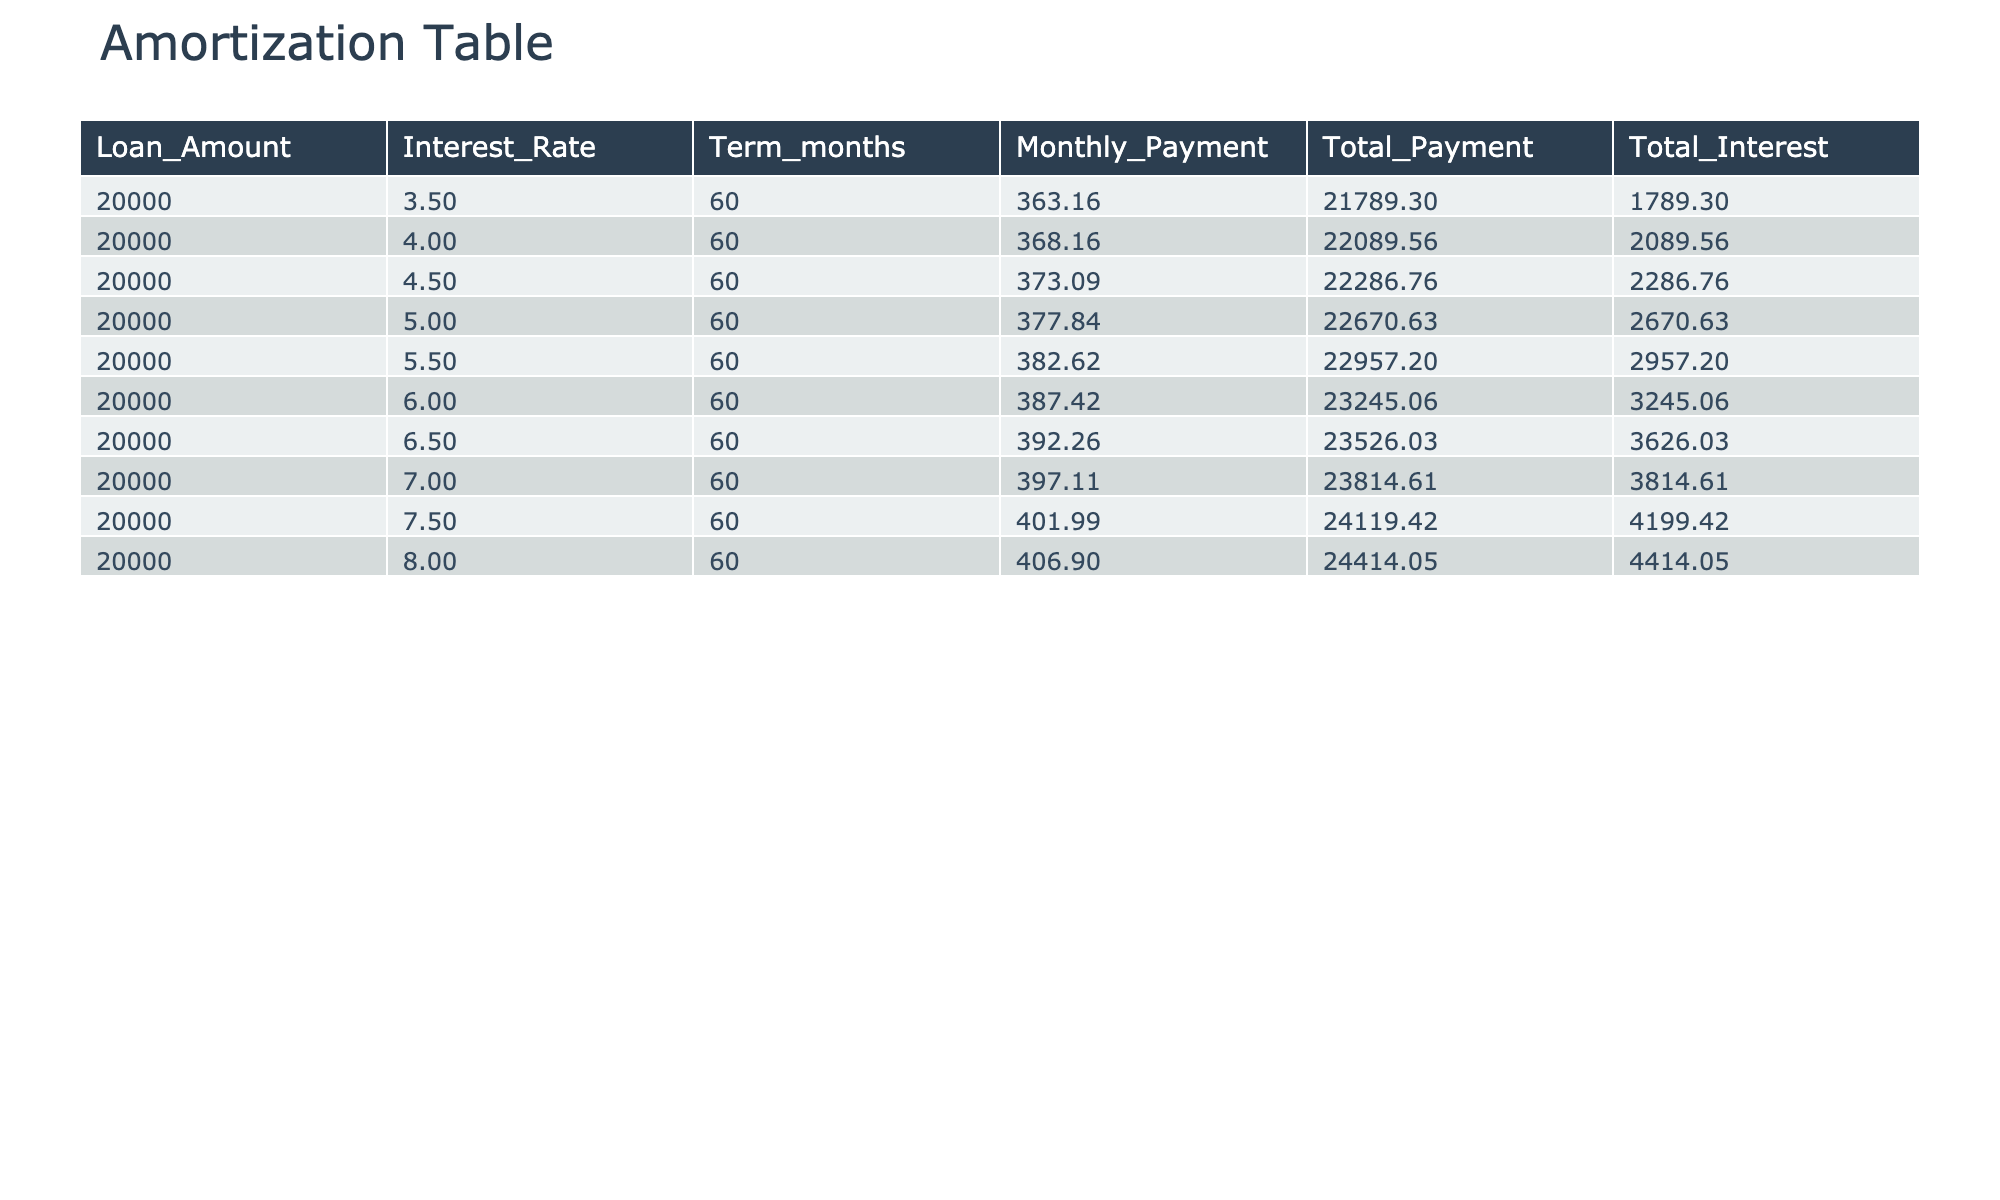What is the monthly payment for a loan at a 5% interest rate? The table shows that for an interest rate of 5.0%, the Monthly Payment column indicates the value is 377.84.
Answer: 377.84 What is the total interest paid for a loan with a 6.5% interest rate? Looking at the Total Interest column, the value corresponding to the 6.5% interest rate in the table is 3626.03.
Answer: 3626.03 How much more will a borrower pay in total for a loan at 7.5% interest compared to a loan at 4% interest? The Total Payment for 7.5% is 24119.42 and for 4% is 22089.56. The difference is 24119.42 - 22089.56 = 1029.86.
Answer: 1029.86 Is the total payment for a 3.5% interest loan less than 22000? The Total Payment for the 3.5% interest loan is 21789.30, which is indeed less than 22000.
Answer: Yes What is the average total interest paid across all the 60-month loans listed in the table? To find the average, we sum all the Total Interest values: (1789.30 + 2089.56 + 2286.76 + 2670.63 + 2957.20 + 3245.06 + 3626.03 + 3814.61 + 4199.42 + 4414.05) = 27610.32, then divide by 10 (the number of loans) to get 2761.03.
Answer: 2761.03 What amount is paid in total for the loan with the highest interest rate listed? The highest interest rate in the table is 8.0%, and the Total Payment associated with it is 24414.05.
Answer: 24414.05 How much does the monthly payment increase for each 0.5% increase in interest rate from 4% to 5.5%? For 4% the monthly payment is 368.16 and for 5.5% it's 382.62. The increase is 382.62 - 368.16 = 14.46.
Answer: 14.46 Is it true that the total payment for a 7% loan is more than 3,000 higher than that of a 5% loan? The total payment for a 7.0% loan is 23814.61 and for a 5% loan is 22670.63. The difference is 23814.61 - 22670.63 = 1143.98, which is not more than 3000.
Answer: No 